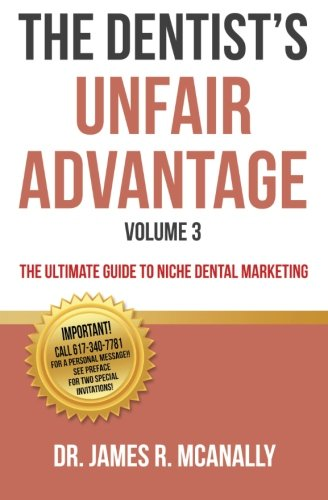Is this a pharmaceutical book? No, this book is not about pharmaceuticals; it specifically focuses on niche marketing strategies for dental practices. 